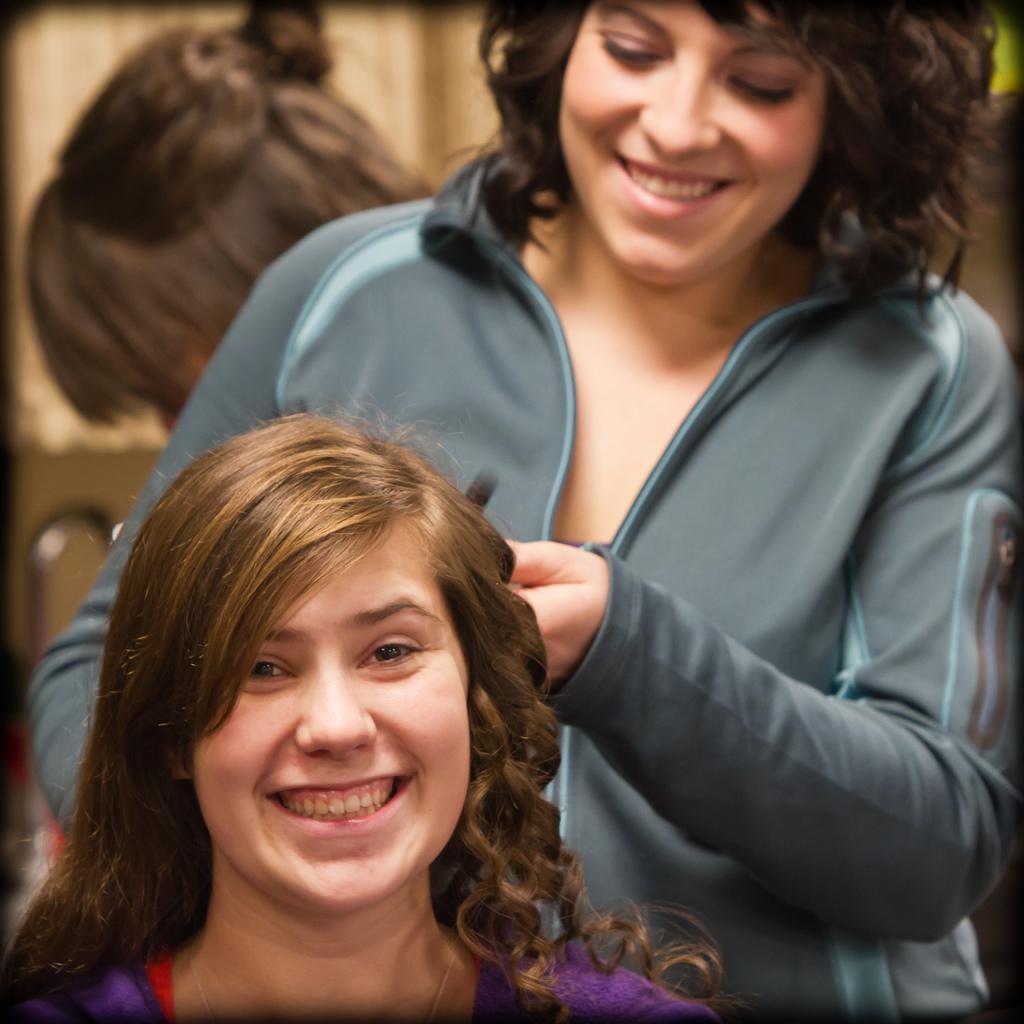Can you describe this image briefly? A woman is sitting. Another woman is standing and curling her hair. 